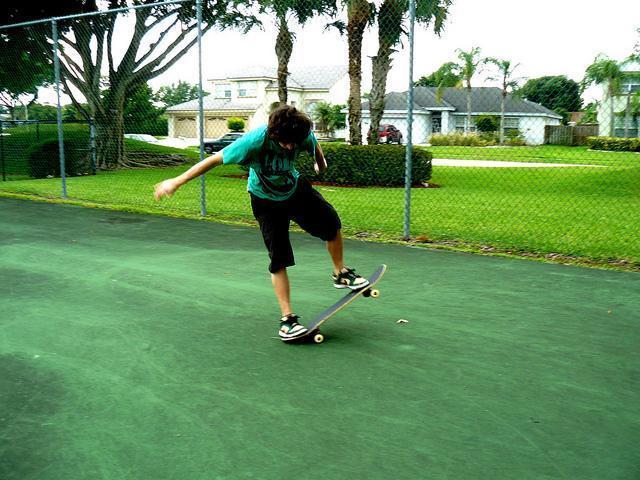How many people are in this photo?
Give a very brief answer. 1. How many people are in the photo?
Give a very brief answer. 1. How many elephant trunks can you see in the picture?
Give a very brief answer. 0. 